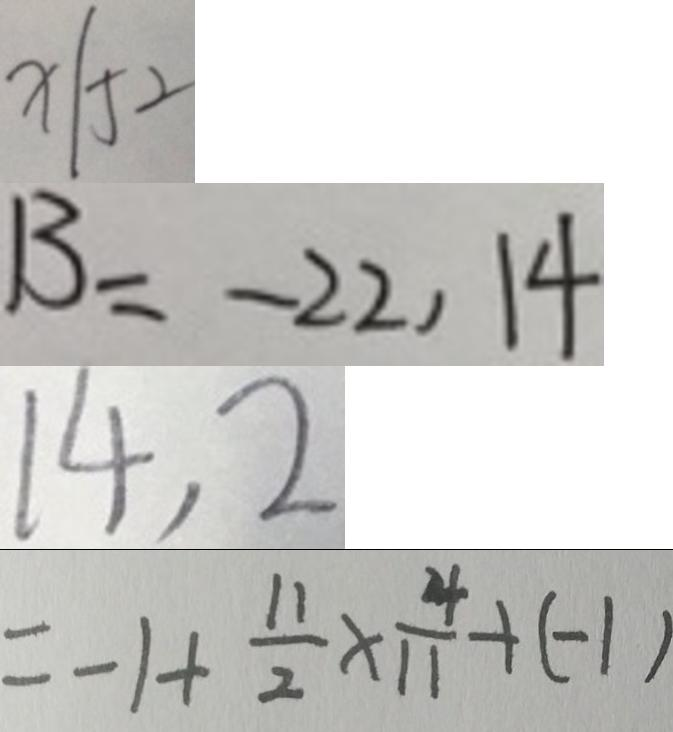<formula> <loc_0><loc_0><loc_500><loc_500>X \vert 5 2 
 B = - 2 2 , 1 4 
 1 4 , 2 
 = - 1 + \frac { 1 1 } { 2 } \times \frac { 4 } { 1 1 } + ( - 1 )</formula> 